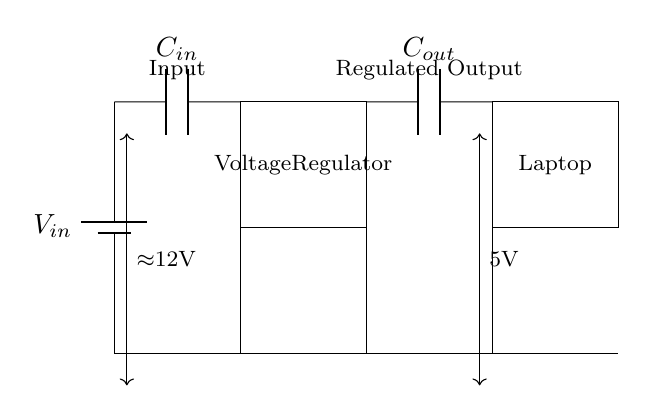What type of circuit is shown? The circuit is a voltage regulator circuit specifically designed for stabilizing power supply to low power appliances like laptops. It regulates the voltage to ensure stable output.
Answer: Voltage regulator circuit What is the input voltage of the circuit? The input voltage is approximately 12 volts, as indicated in the circuit where the voltage is labeled near the input source.
Answer: Approximately 12V What is the regulated output voltage of this circuit? The regulated output voltage is 5 volts, which is clearly labeled in the output section of the circuit diagram.
Answer: 5V What is the function of capacitor C_in? The input capacitor (C_in) filters and stabilizes the input voltage from the battery, reducing voltage fluctuations before reaching the voltage regulator.
Answer: Filter and stabilize How many capacitors are present in this circuit? There are two capacitors present in this circuit: C_in and C_out. This information can be derived from recognizing the elements labeled in the diagram.
Answer: Two Explain the role of the voltage regulator in this circuit. The voltage regulator maintains a constant output voltage (5V) despite variations in input voltage (12V) or the current drawn by the load (laptop). This ensures that the laptop operates safely and efficiently within its voltage requirements.
Answer: Maintains constant output voltage 